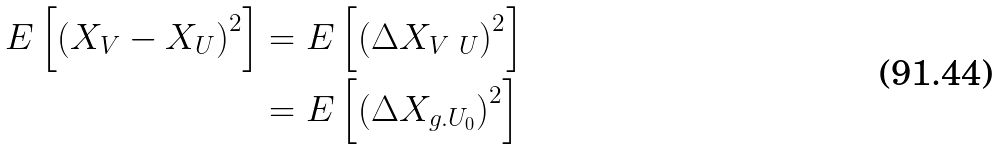Convert formula to latex. <formula><loc_0><loc_0><loc_500><loc_500>E \left [ \left ( X _ { V } - X _ { U } \right ) ^ { 2 } \right ] & = E \left [ \left ( \Delta X _ { V \ U } \right ) ^ { 2 } \right ] \\ & = E \left [ \left ( \Delta X _ { g . U _ { 0 } } \right ) ^ { 2 } \right ]</formula> 